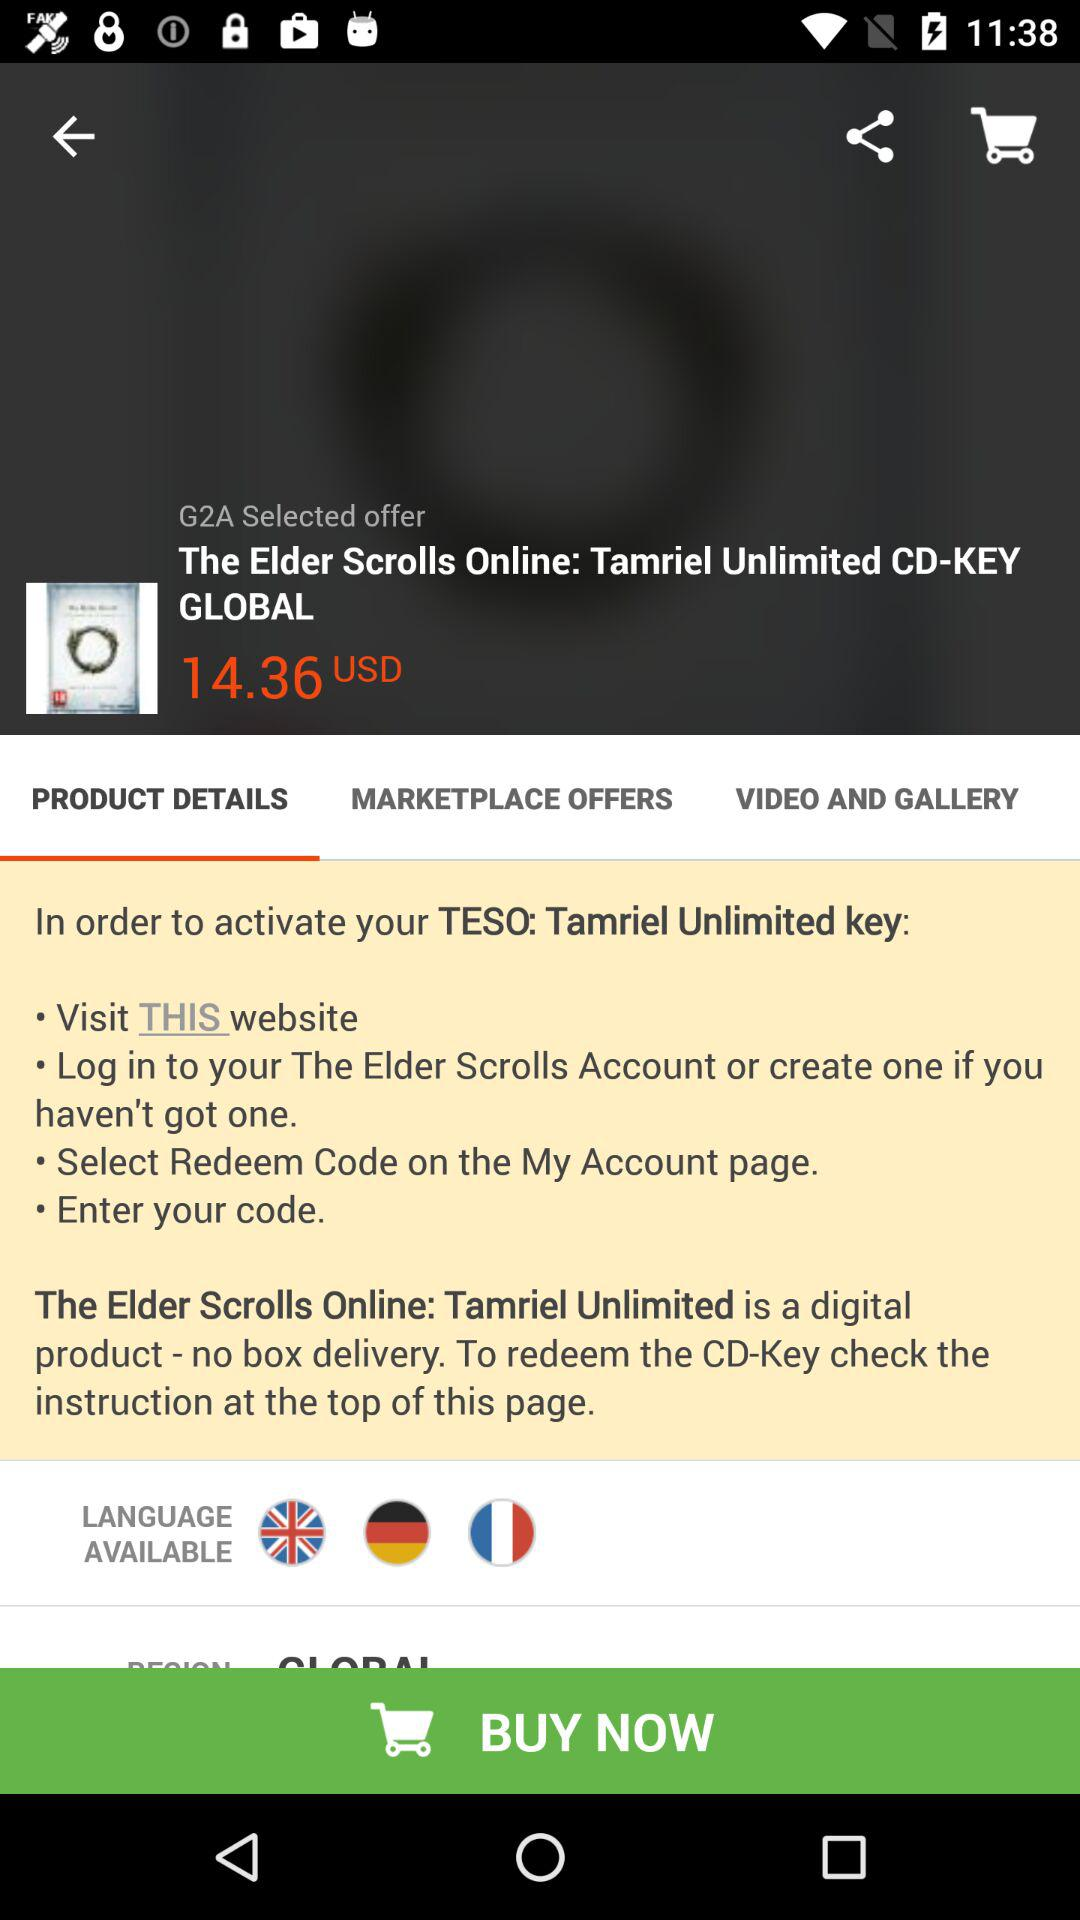Which tab has been selected? The tab that has been selected is "PRODUCT DETAILS". 